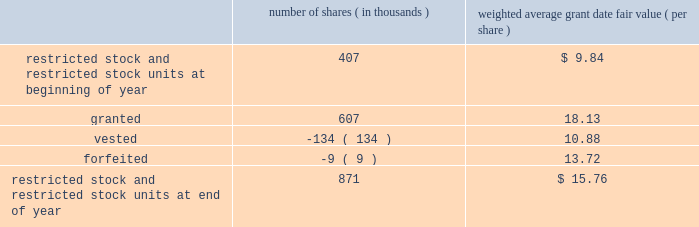Abiomed , inc .
And subsidiaries notes to consolidated financial statements 2014 ( continued ) note 8 .
Stock award plans and stock-based compensation ( continued ) restricted stock and restricted stock units the table summarizes restricted stock and restricted stock unit activity for the fiscal year ended march 31 , 2012 : number of shares ( in thousands ) weighted average grant date fair value ( per share ) .
The remaining unrecognized compensation expense for outstanding restricted stock and restricted stock units , including performance-based awards , as of march 31 , 2012 was $ 7.1 million and the weighted-average period over which this cost will be recognized is 2.2 years .
The weighted average grant-date fair value for restricted stock and restricted stock units granted during the years ended march 31 , 2012 , 2011 , and 2010 was $ 18.13 , $ 10.00 and $ 7.67 per share , respectively .
The total fair value of restricted stock and restricted stock units vested in fiscal years 2012 , 2011 , and 2010 was $ 1.5 million , $ 1.0 million and $ 0.4 million , respectively .
Performance-based awards included in the restricted stock and restricted stock units activity discussed above are certain awards granted in fiscal years 2012 , 2011 and 2010 that vest subject to certain performance-based criteria .
In june 2010 , 311000 shares of restricted stock and a performance-based award for the potential issuance of 45000 shares of common stock were issued to certain executive officers and members of senior management of the company , all of which would vest upon achievement of prescribed service milestones by the award recipients and performance milestones by the company .
During the year ended march 31 , 2011 , the company determined that it met the prescribed performance targets and a portion of these shares and stock options vested .
The remaining shares will vest upon satisfaction of prescribed service conditions by the award recipients .
During the three months ended june 30 , 2011 , the company determined that it should have been using the graded vesting method instead of the straight-line method to expense stock-based compensation for the performance-based awards issued in june 2010 .
This resulted in additional stock based compensation expense of approximately $ 0.6 million being recorded during the three months ended june 30 , 2011 that should have been recorded during the year ended march 31 , 2011 .
The company believes that the amount is not material to its march 31 , 2011 consolidated financial statements and therefore recorded the adjustment in the quarter ended june 30 , 2011 .
During the three months ended june 30 , 2011 , performance-based awards of restricted stock units for the potential issuance of 284000 shares of common stock were issued to certain executive officers and members of the senior management , all of which would vest upon achievement of prescribed service milestones by the award recipients and revenue performance milestones by the company .
As of march 31 , 2012 , the company determined that it met the prescribed targets for 184000 shares underlying these awards and it believes it is probable that the prescribed performance targets will be met for the remaining 100000 shares , and the compensation expense is being recognized accordingly .
During the year ended march 31 , 2012 , the company has recorded $ 3.3 million in stock-based compensation expense for equity awards in which the prescribed performance milestones have been achieved or are probable of being achieved .
The remaining unrecognized compensation expense related to these equity awards at march 31 , 2012 is $ 3.6 million based on the company 2019s current assessment of probability of achieving the performance milestones .
The weighted-average period over which this cost will be recognized is 2.1 years. .
During the 2012 year , did the equity awards in which the prescribed performance milestones were achieved exceed the equity award compensation expense for equity granted during the year? 
Computations: (((607 * 18.13) * 1000) > (3.3 * 1000000))
Answer: yes. 